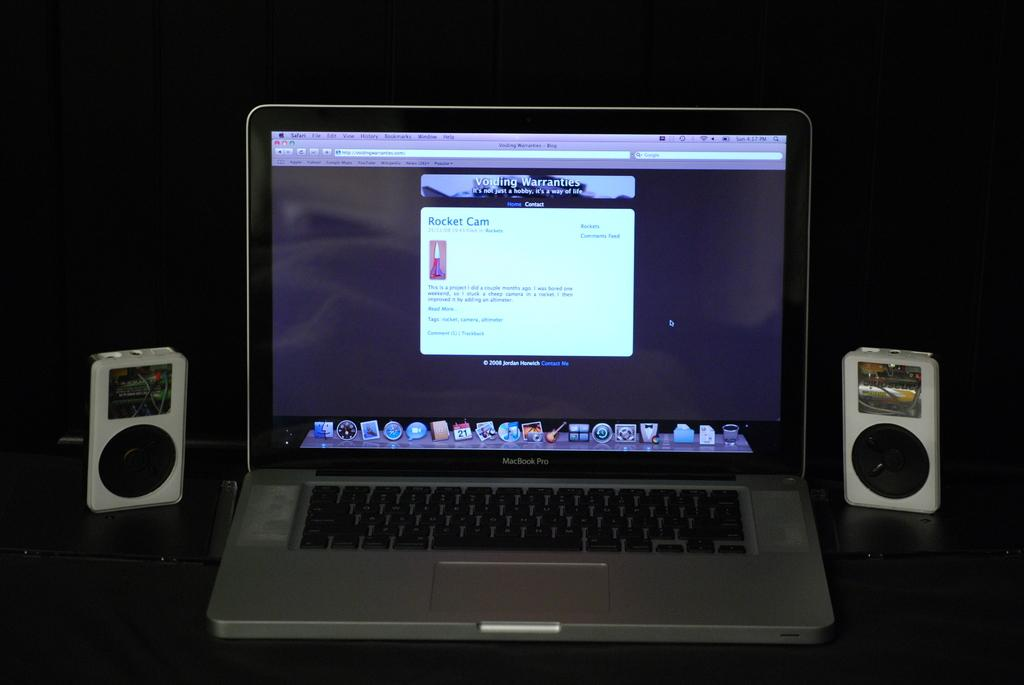What electronic device is visible in the image? There is a laptop in the image. What other electronic device is present in the image? There are speakers beside the laptop. What is the color of the background in the image? The background of the image is dark. What winter activity is being performed in the image? There is no winter activity present in the image; it features a laptop and speakers. How many statements can be seen written on the laptop screen in the image? There is no information about any statements written on the laptop screen in the image. 